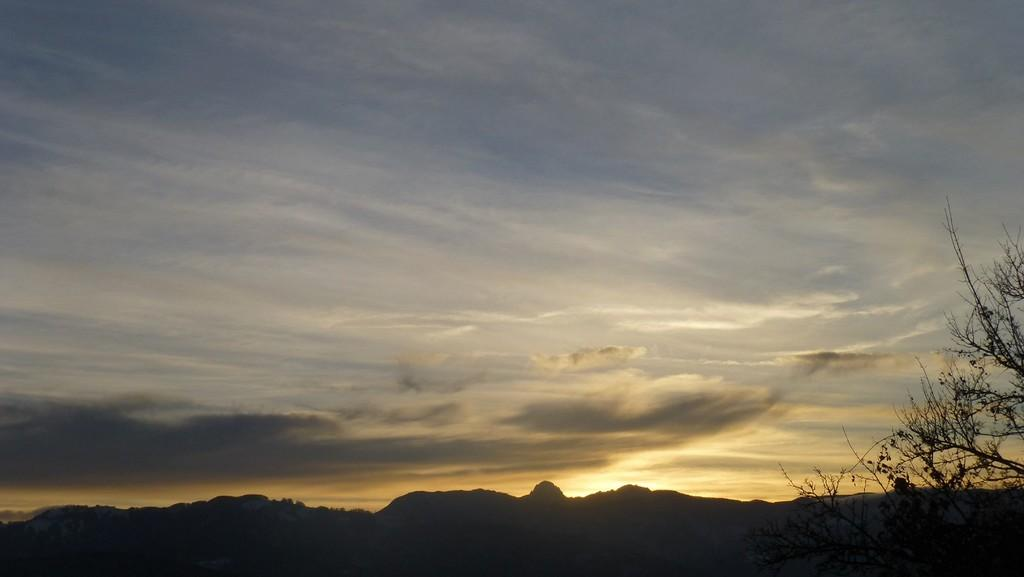What type of natural formation can be seen in the image? There are mountains visible in the image. What else is visible in the background of the image? The sky is visible in the background of the image. Where is the tree located in the image? There is a tree in the bottom right corner of the image. What type of board is being used to surf on the mountains in the image? There is no board or surfing activity present in the image; it features mountains and a tree. What type of vessel is visible in the sky in the image? There is no vessel present in the sky in the image; it features mountains, a tree, and the sky. 